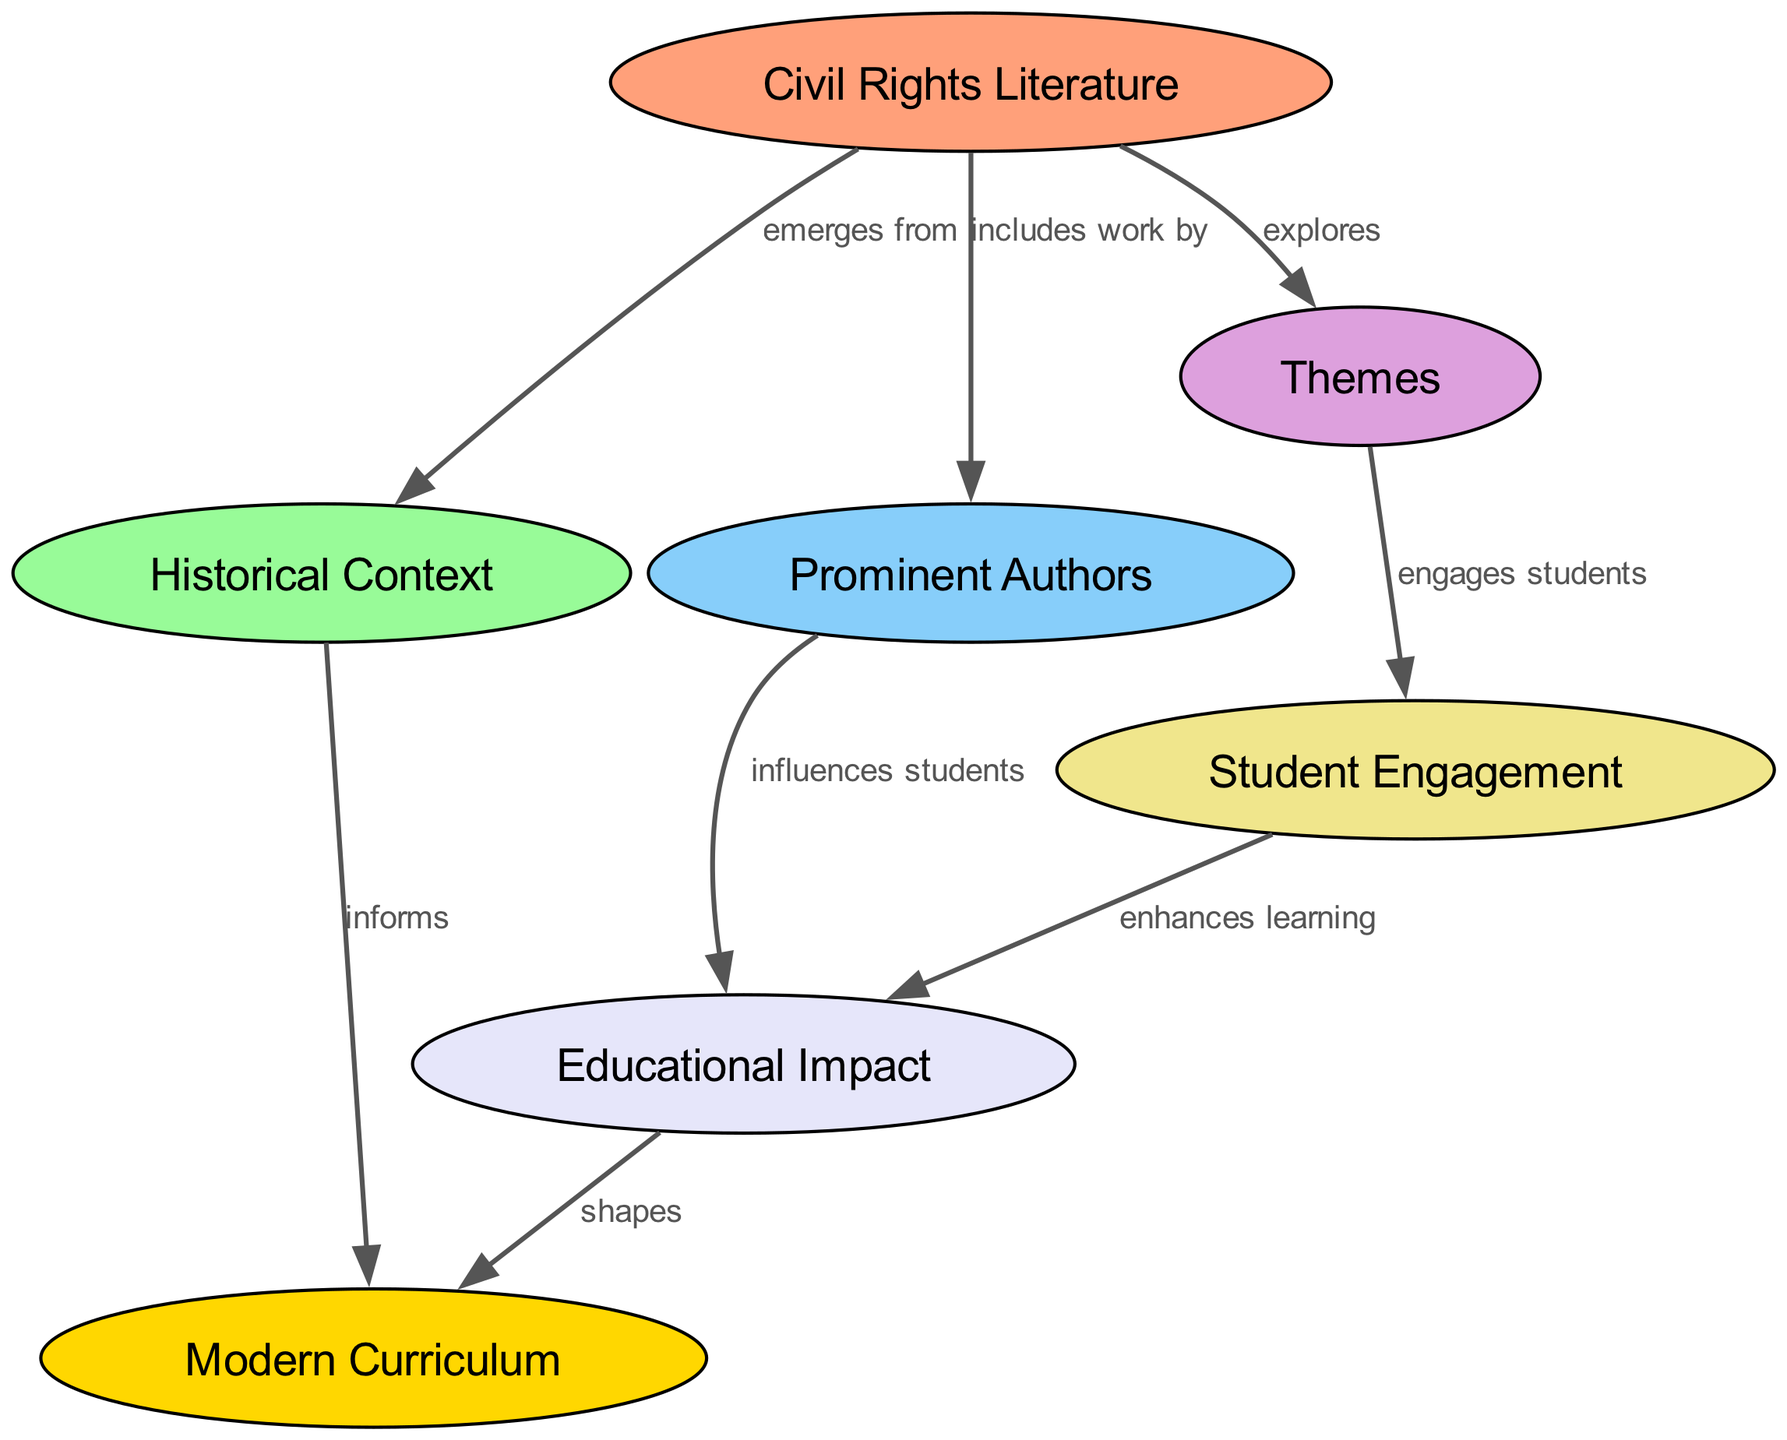What is the main subject of the diagram? The title of the diagram illustrates that the focus is on "Civil Rights Literature," as indicated in the central node labeled "Civil Rights Literature."
Answer: Civil Rights Literature How many nodes are there in the diagram? By counting the nodes present in the diagram, we see there are a total of seven distinct nodes listed, each representing different aspects of civil rights literature and its impact.
Answer: 7 Which node discusses the influence of authors? The node labeled "Prominent Authors" directly addresses the key figures in civil rights literature and their contributions, as indicated by the explicit connection from "Civil Rights Literature" to this node.
Answer: Prominent Authors What relationship exists between "Themes" and "Student Engagement"? The diagram shows that "Themes" engages students, illustrated by the edge labeled "engages students" connecting "Themes" to "Student Engagement." This highlights how the thematic content of civil rights literature captivates students' interests.
Answer: engages students How does "Historical Context" relate to "Modern Curriculum"? The edge labeled "informs" indicates that the “Historical Context” of civil rights literature directly informs the development and design of the “Modern Curriculum,” suggesting a historical basis for current educational approaches.
Answer: informs What effect does "Student Engagement" have on "Educational Impact"? The diagram shows that "Student Engagement" enhances learning, as conveyed by the edge "enhances learning," which links these two nodes and suggests that when students are engaged, their overall educational impact increases positively.
Answer: enhances learning Which element directly influences students according to the diagram? The node “Prominent Authors” is explicitly connected to the “Educational Impact” node, showing that literature from noteworthy authors is a significant influence on students’ learning experiences.
Answer: influences students What does “Educational Impact” do to "Modern Curriculum"? The diagram illustrates that "Educational Impact" shapes "Modern Curriculum," as indicated by the connecting edge labeled "shapes," suggesting that the overarching impacts of education affect how curriculums are structured today.
Answer: shapes 